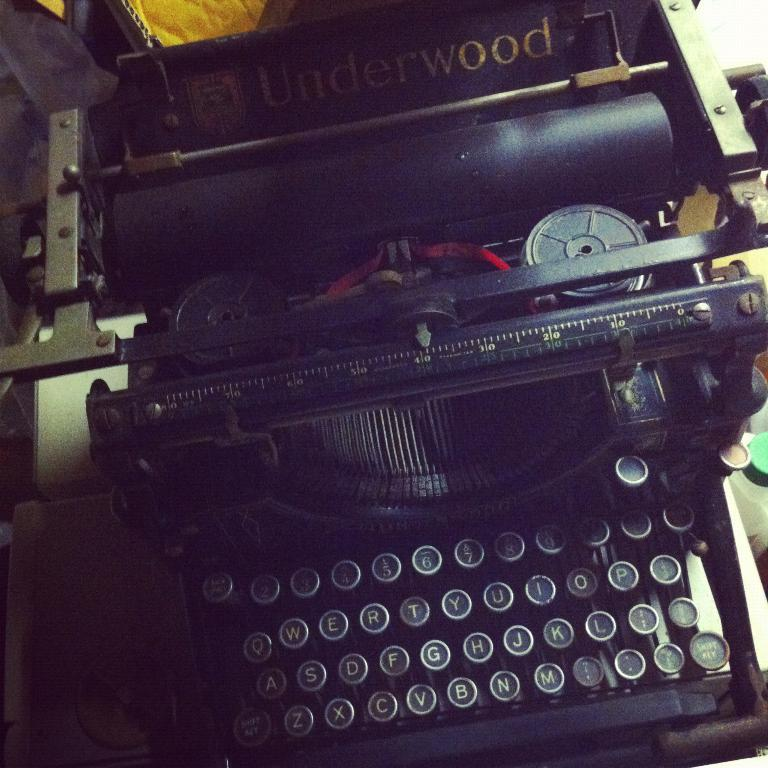Provide a one-sentence caption for the provided image. old black manual typewriter that has Underwood labeled toward the back of it. 